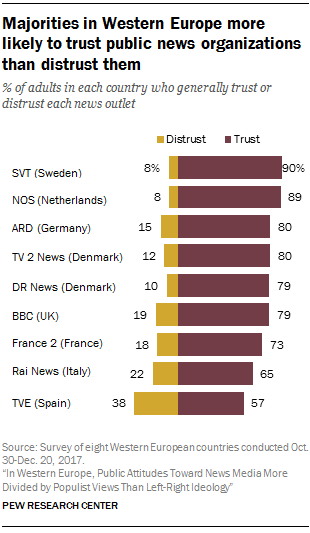Point out several critical features in this image. According to a recent survey, 79% of adults in the UK trust the BBC. As of the 79 values available, the occurrence of the Trust bar is X. 